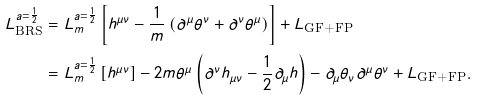<formula> <loc_0><loc_0><loc_500><loc_500>L _ { \text {BRS} } ^ { a = \frac { 1 } { 2 } } & = L _ { m } ^ { a = \frac { 1 } { 2 } } \left [ h ^ { \mu \nu } - \frac { 1 } { m } \left ( \partial ^ { \mu } \theta ^ { \nu } + \partial ^ { \nu } \theta ^ { \mu } \right ) \right ] + L _ { \text {GF+FP} } \\ & = L _ { m } ^ { a = \frac { 1 } { 2 } } \left [ h ^ { \mu \nu } \right ] - 2 m \theta ^ { \mu } \left ( \partial ^ { \nu } h _ { \mu \nu } - \frac { 1 } { 2 } \partial _ { \mu } h \right ) - \partial _ { \mu } \theta _ { \nu } \partial ^ { \mu } \theta ^ { \nu } + L _ { \text {GF+FP} } .</formula> 